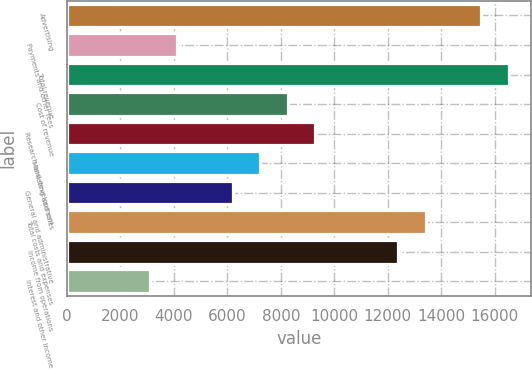Convert chart to OTSL. <chart><loc_0><loc_0><loc_500><loc_500><bar_chart><fcel>Advertising<fcel>Payments and other fees<fcel>Total revenue<fcel>Cost of revenue<fcel>Research and development<fcel>Marketing and sales<fcel>General and administrative<fcel>Total costs and expenses<fcel>Income from operations<fcel>Interest and other income<nl><fcel>15491.2<fcel>4132.15<fcel>16523.8<fcel>8262.71<fcel>9295.35<fcel>7230.07<fcel>6197.43<fcel>13425.9<fcel>12393.3<fcel>3099.51<nl></chart> 